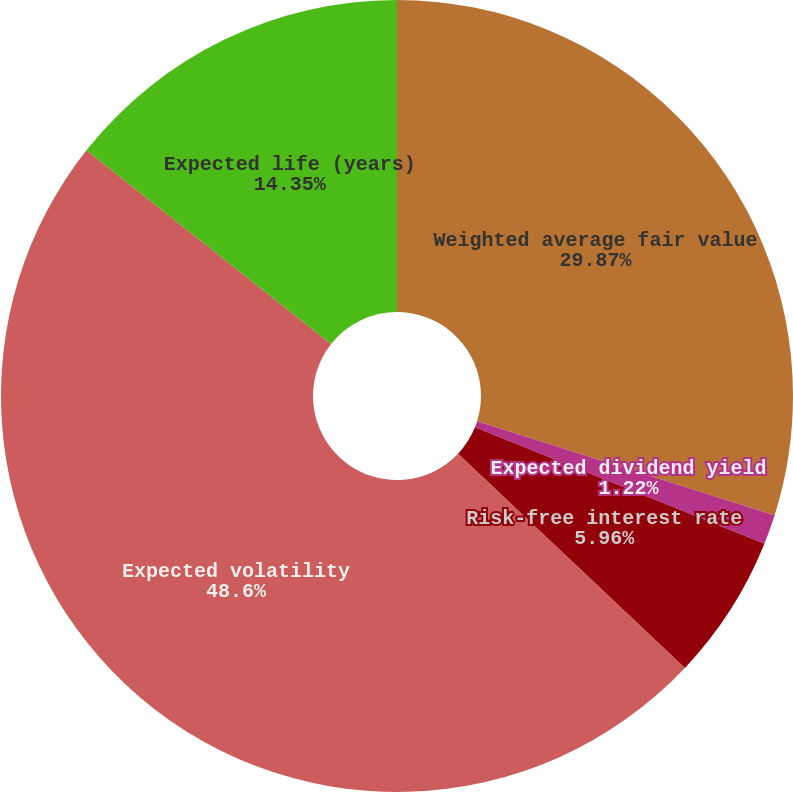Convert chart to OTSL. <chart><loc_0><loc_0><loc_500><loc_500><pie_chart><fcel>Weighted average fair value<fcel>Expected dividend yield<fcel>Risk-free interest rate<fcel>Expected volatility<fcel>Expected life (years)<nl><fcel>29.87%<fcel>1.22%<fcel>5.96%<fcel>48.61%<fcel>14.35%<nl></chart> 